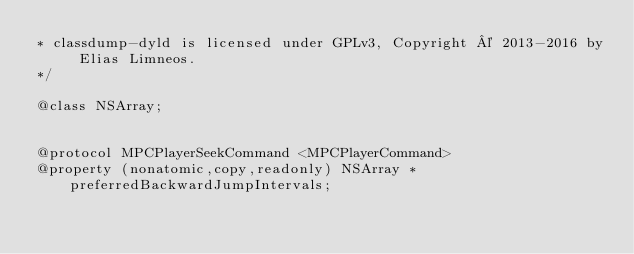<code> <loc_0><loc_0><loc_500><loc_500><_C_>* classdump-dyld is licensed under GPLv3, Copyright © 2013-2016 by Elias Limneos.
*/

@class NSArray;


@protocol MPCPlayerSeekCommand <MPCPlayerCommand>
@property (nonatomic,copy,readonly) NSArray * preferredBackwardJumpIntervals; </code> 